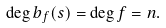<formula> <loc_0><loc_0><loc_500><loc_500>\deg b _ { f } ( s ) = \deg f = n .</formula> 